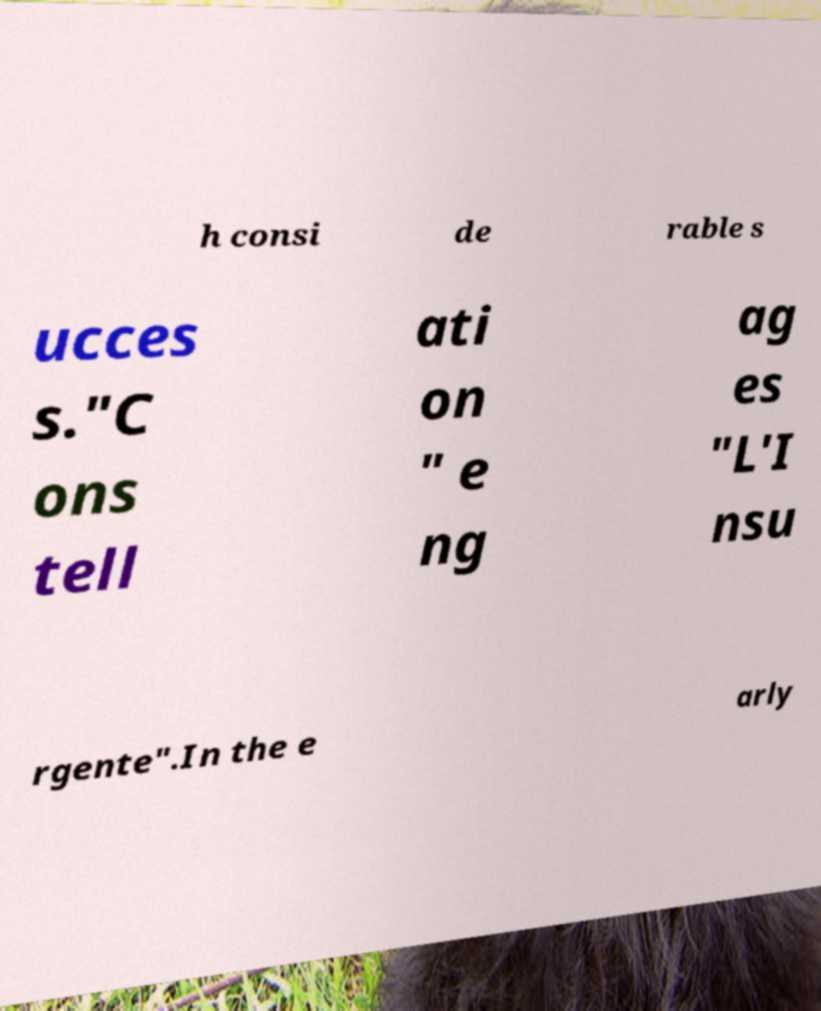Can you read and provide the text displayed in the image?This photo seems to have some interesting text. Can you extract and type it out for me? h consi de rable s ucces s."C ons tell ati on " e ng ag es "L'I nsu rgente".In the e arly 